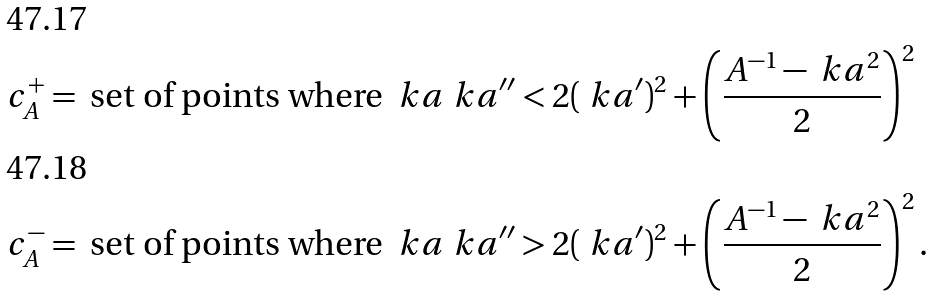Convert formula to latex. <formula><loc_0><loc_0><loc_500><loc_500>c ^ { + } _ { A } & = \text { set of points where } \ k a \ k a ^ { \prime \prime } < 2 ( \ k a ^ { \prime } ) ^ { 2 } + \left ( \frac { A ^ { - 1 } - \ k a ^ { 2 } } 2 \right ) ^ { 2 } \\ c ^ { - } _ { A } & = \text { set of points where } \ k a \ k a ^ { \prime \prime } > 2 ( \ k a ^ { \prime } ) ^ { 2 } + \left ( \frac { A ^ { - 1 } - \ k a ^ { 2 } } 2 \right ) ^ { 2 } .</formula> 